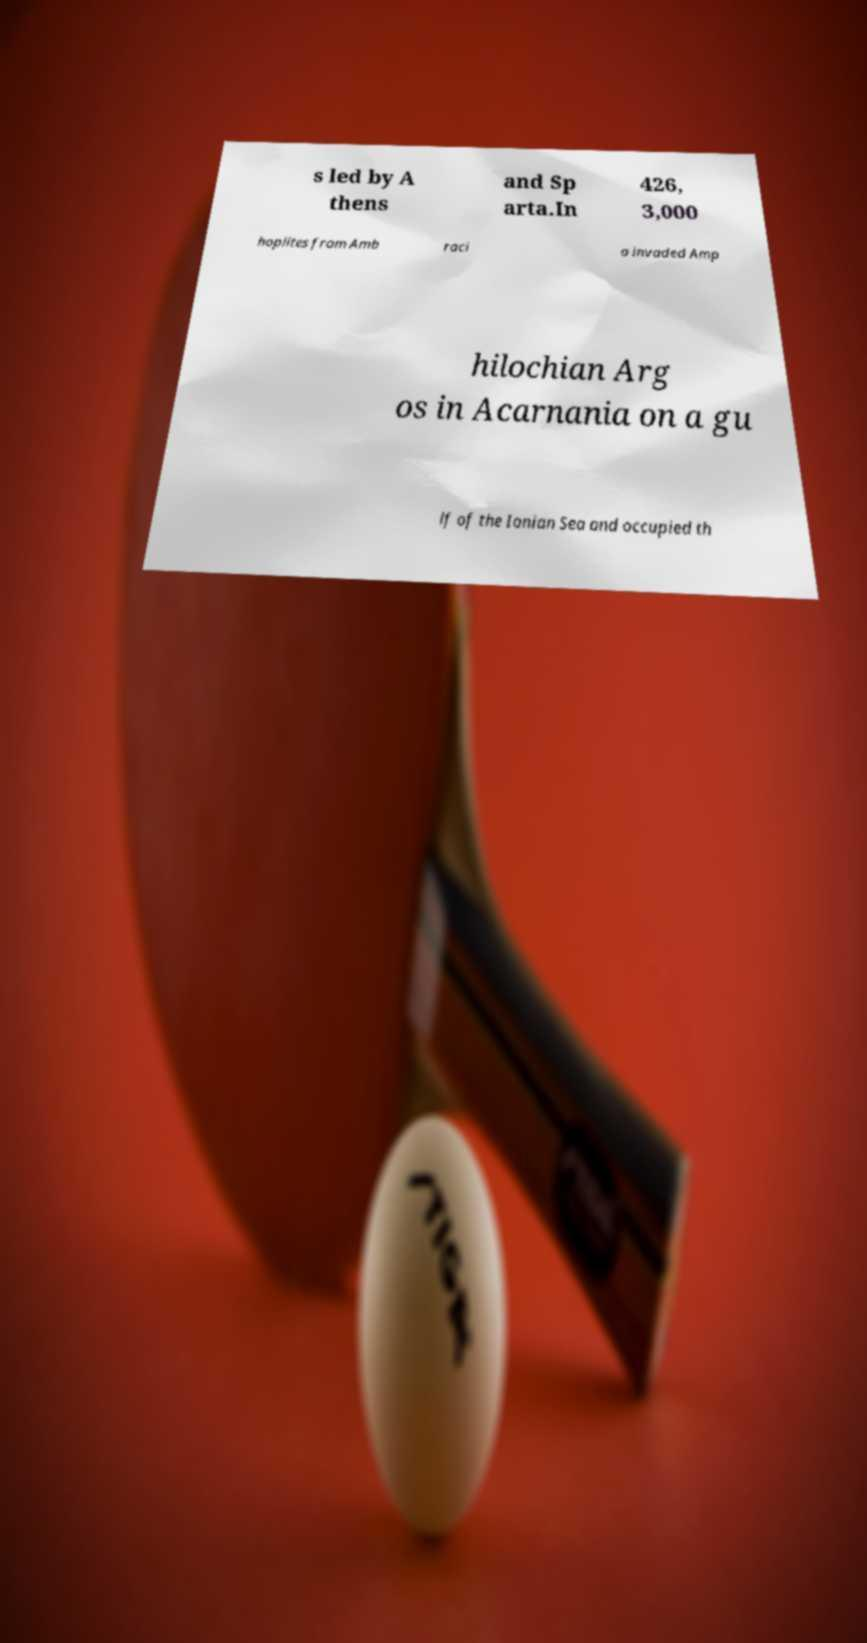There's text embedded in this image that I need extracted. Can you transcribe it verbatim? s led by A thens and Sp arta.In 426, 3,000 hoplites from Amb raci a invaded Amp hilochian Arg os in Acarnania on a gu lf of the Ionian Sea and occupied th 